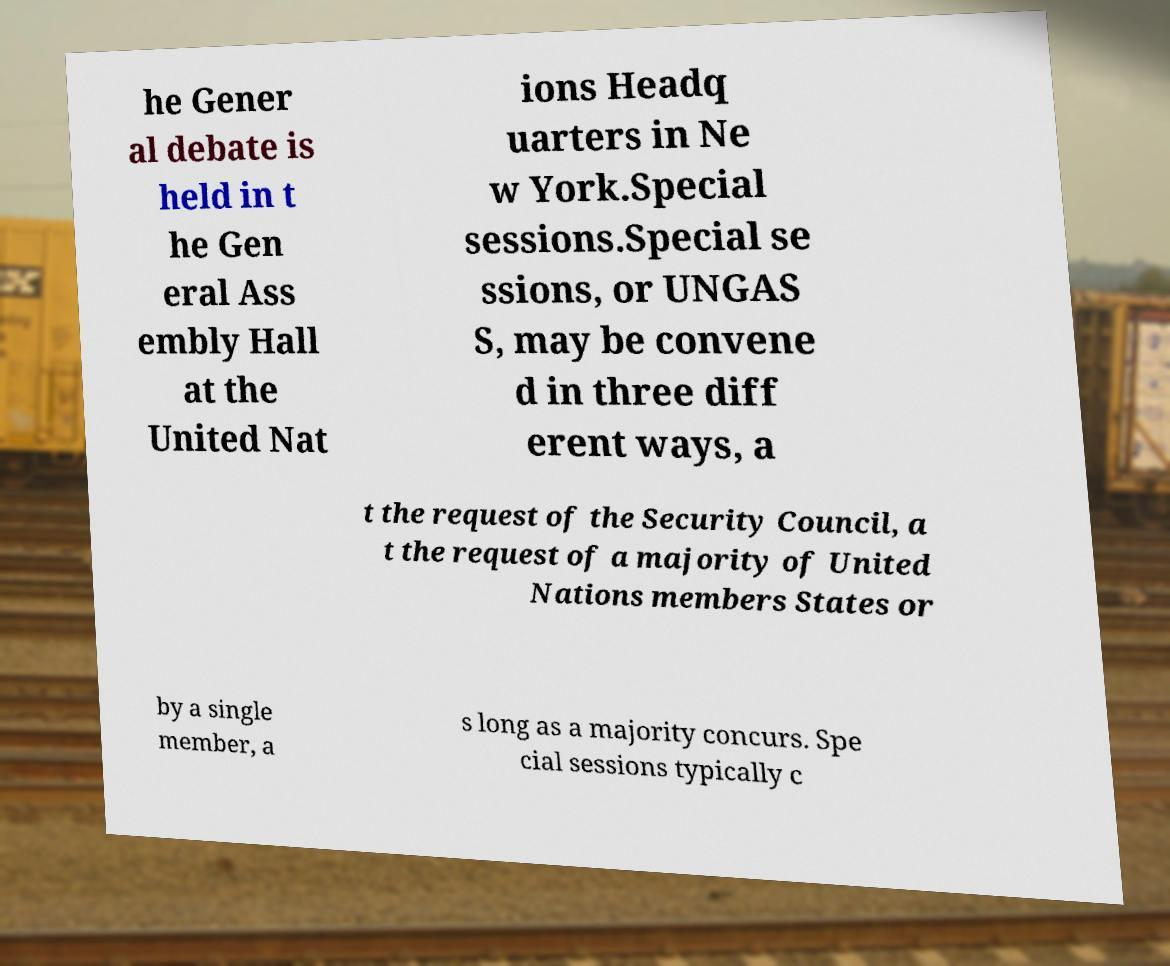Please read and relay the text visible in this image. What does it say? he Gener al debate is held in t he Gen eral Ass embly Hall at the United Nat ions Headq uarters in Ne w York.Special sessions.Special se ssions, or UNGAS S, may be convene d in three diff erent ways, a t the request of the Security Council, a t the request of a majority of United Nations members States or by a single member, a s long as a majority concurs. Spe cial sessions typically c 